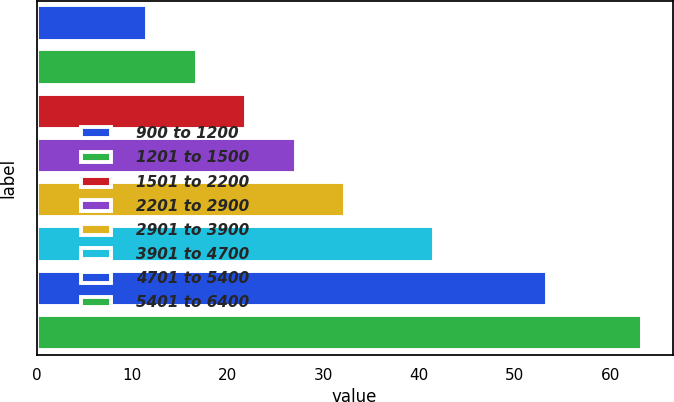Convert chart. <chart><loc_0><loc_0><loc_500><loc_500><bar_chart><fcel>900 to 1200<fcel>1201 to 1500<fcel>1501 to 2200<fcel>2201 to 2900<fcel>2901 to 3900<fcel>3901 to 4700<fcel>4701 to 5400<fcel>5401 to 6400<nl><fcel>11.57<fcel>16.75<fcel>21.93<fcel>27.11<fcel>32.29<fcel>41.54<fcel>53.4<fcel>63.35<nl></chart> 